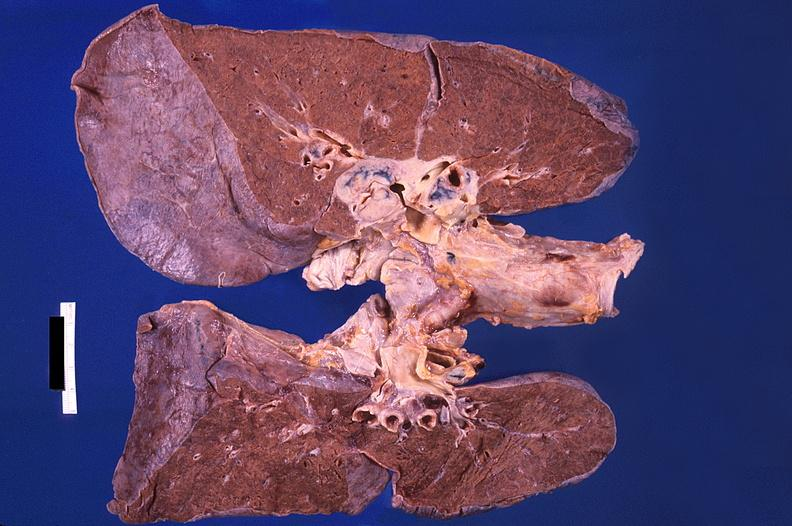s respiratory present?
Answer the question using a single word or phrase. Yes 